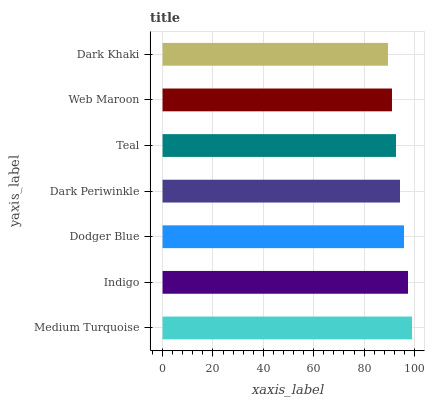Is Dark Khaki the minimum?
Answer yes or no. Yes. Is Medium Turquoise the maximum?
Answer yes or no. Yes. Is Indigo the minimum?
Answer yes or no. No. Is Indigo the maximum?
Answer yes or no. No. Is Medium Turquoise greater than Indigo?
Answer yes or no. Yes. Is Indigo less than Medium Turquoise?
Answer yes or no. Yes. Is Indigo greater than Medium Turquoise?
Answer yes or no. No. Is Medium Turquoise less than Indigo?
Answer yes or no. No. Is Dark Periwinkle the high median?
Answer yes or no. Yes. Is Dark Periwinkle the low median?
Answer yes or no. Yes. Is Dark Khaki the high median?
Answer yes or no. No. Is Medium Turquoise the low median?
Answer yes or no. No. 